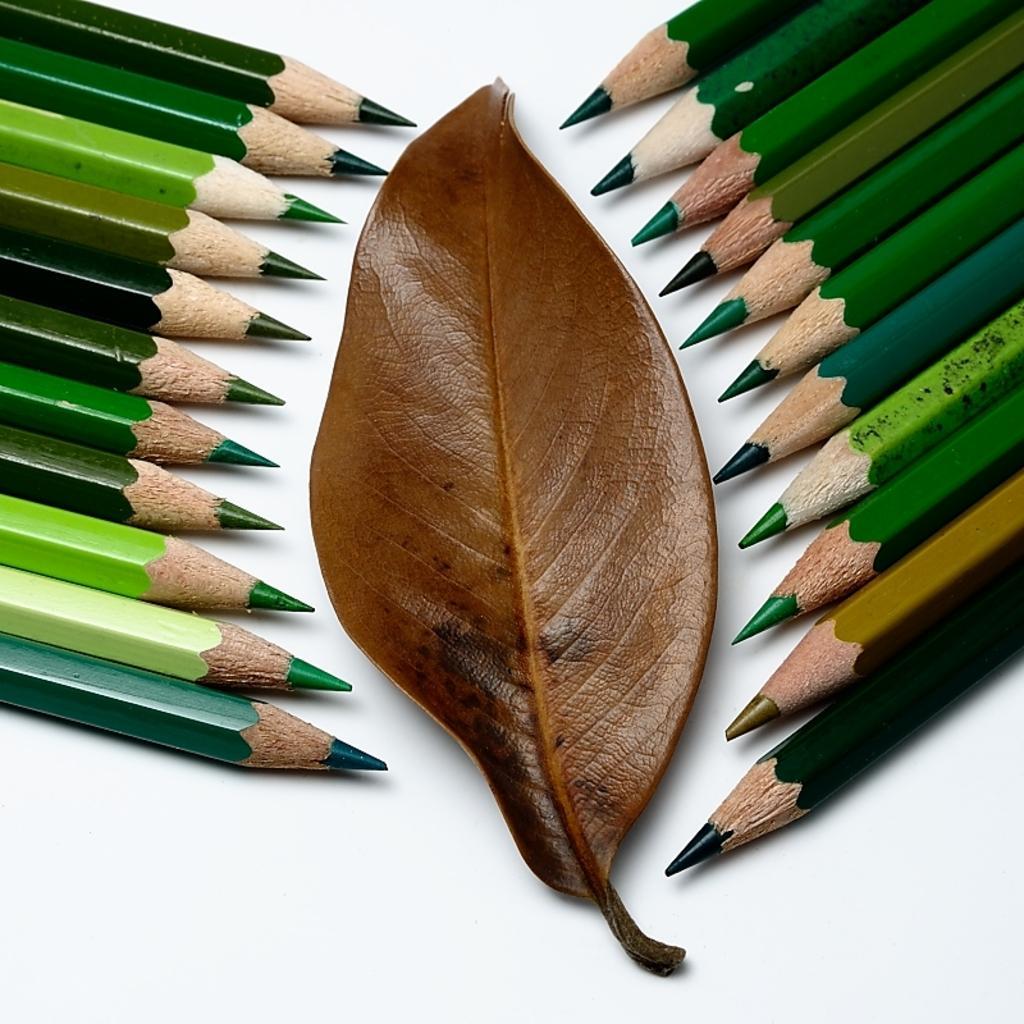Can you describe this image briefly? In this image there are color pencils and a leaf is on the white surface.   